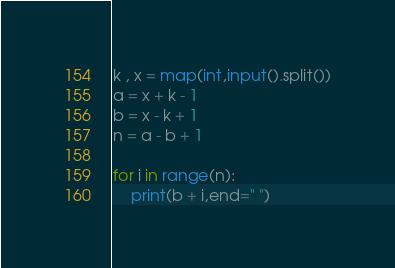<code> <loc_0><loc_0><loc_500><loc_500><_Python_>k , x = map(int,input().split())
a = x + k - 1
b = x - k + 1
n = a - b + 1

for i in range(n):
    print(b + i,end=" ")
</code> 